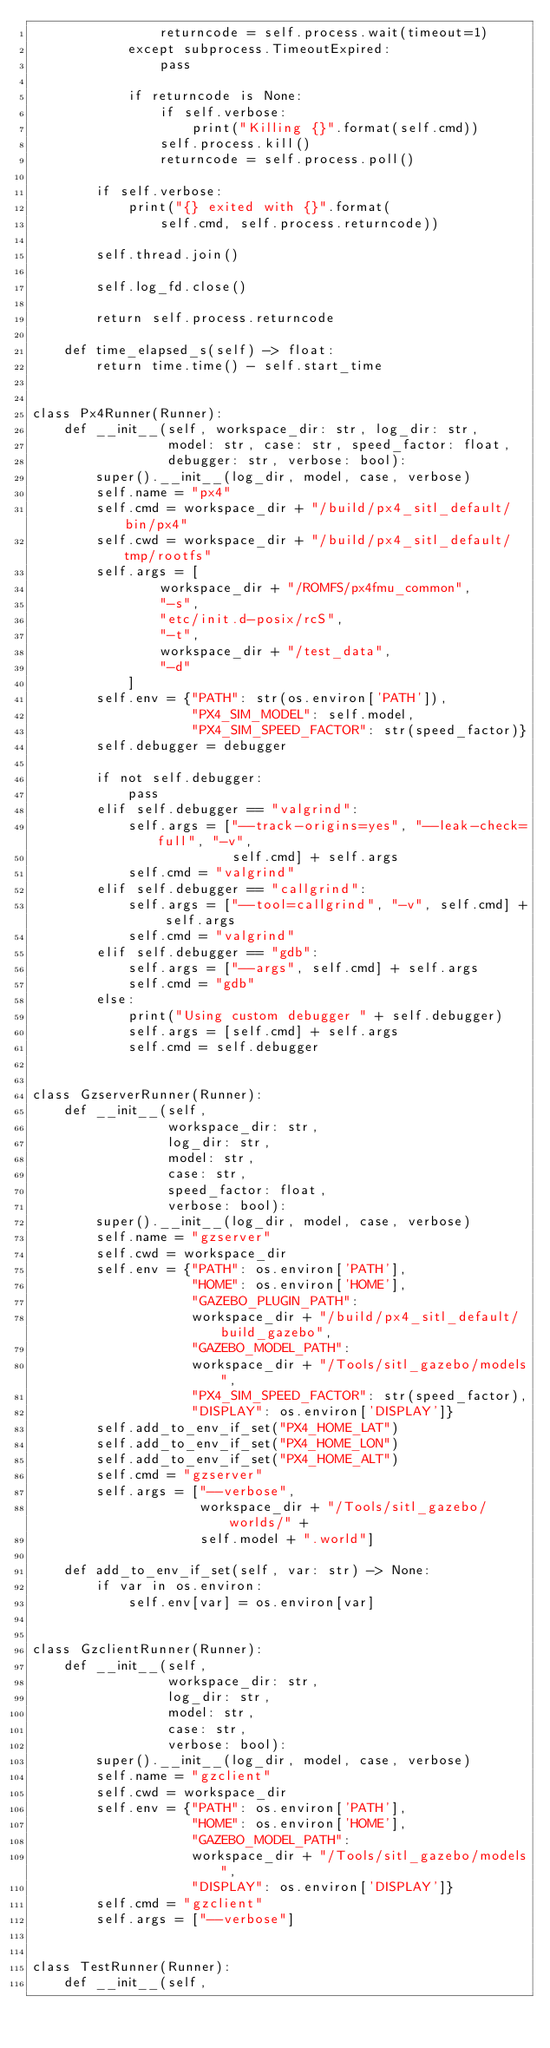<code> <loc_0><loc_0><loc_500><loc_500><_Python_>                returncode = self.process.wait(timeout=1)
            except subprocess.TimeoutExpired:
                pass

            if returncode is None:
                if self.verbose:
                    print("Killing {}".format(self.cmd))
                self.process.kill()
                returncode = self.process.poll()

        if self.verbose:
            print("{} exited with {}".format(
                self.cmd, self.process.returncode))

        self.thread.join()

        self.log_fd.close()

        return self.process.returncode

    def time_elapsed_s(self) -> float:
        return time.time() - self.start_time


class Px4Runner(Runner):
    def __init__(self, workspace_dir: str, log_dir: str,
                 model: str, case: str, speed_factor: float,
                 debugger: str, verbose: bool):
        super().__init__(log_dir, model, case, verbose)
        self.name = "px4"
        self.cmd = workspace_dir + "/build/px4_sitl_default/bin/px4"
        self.cwd = workspace_dir + "/build/px4_sitl_default/tmp/rootfs"
        self.args = [
                workspace_dir + "/ROMFS/px4fmu_common",
                "-s",
                "etc/init.d-posix/rcS",
                "-t",
                workspace_dir + "/test_data",
                "-d"
            ]
        self.env = {"PATH": str(os.environ['PATH']),
                    "PX4_SIM_MODEL": self.model,
                    "PX4_SIM_SPEED_FACTOR": str(speed_factor)}
        self.debugger = debugger

        if not self.debugger:
            pass
        elif self.debugger == "valgrind":
            self.args = ["--track-origins=yes", "--leak-check=full", "-v",
                         self.cmd] + self.args
            self.cmd = "valgrind"
        elif self.debugger == "callgrind":
            self.args = ["--tool=callgrind", "-v", self.cmd] + self.args
            self.cmd = "valgrind"
        elif self.debugger == "gdb":
            self.args = ["--args", self.cmd] + self.args
            self.cmd = "gdb"
        else:
            print("Using custom debugger " + self.debugger)
            self.args = [self.cmd] + self.args
            self.cmd = self.debugger


class GzserverRunner(Runner):
    def __init__(self,
                 workspace_dir: str,
                 log_dir: str,
                 model: str,
                 case: str,
                 speed_factor: float,
                 verbose: bool):
        super().__init__(log_dir, model, case, verbose)
        self.name = "gzserver"
        self.cwd = workspace_dir
        self.env = {"PATH": os.environ['PATH'],
                    "HOME": os.environ['HOME'],
                    "GAZEBO_PLUGIN_PATH":
                    workspace_dir + "/build/px4_sitl_default/build_gazebo",
                    "GAZEBO_MODEL_PATH":
                    workspace_dir + "/Tools/sitl_gazebo/models",
                    "PX4_SIM_SPEED_FACTOR": str(speed_factor),
                    "DISPLAY": os.environ['DISPLAY']}
        self.add_to_env_if_set("PX4_HOME_LAT")
        self.add_to_env_if_set("PX4_HOME_LON")
        self.add_to_env_if_set("PX4_HOME_ALT")
        self.cmd = "gzserver"
        self.args = ["--verbose",
                     workspace_dir + "/Tools/sitl_gazebo/worlds/" +
                     self.model + ".world"]

    def add_to_env_if_set(self, var: str) -> None:
        if var in os.environ:
            self.env[var] = os.environ[var]


class GzclientRunner(Runner):
    def __init__(self,
                 workspace_dir: str,
                 log_dir: str,
                 model: str,
                 case: str,
                 verbose: bool):
        super().__init__(log_dir, model, case, verbose)
        self.name = "gzclient"
        self.cwd = workspace_dir
        self.env = {"PATH": os.environ['PATH'],
                    "HOME": os.environ['HOME'],
                    "GAZEBO_MODEL_PATH":
                    workspace_dir + "/Tools/sitl_gazebo/models",
                    "DISPLAY": os.environ['DISPLAY']}
        self.cmd = "gzclient"
        self.args = ["--verbose"]


class TestRunner(Runner):
    def __init__(self,</code> 